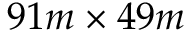<formula> <loc_0><loc_0><loc_500><loc_500>9 1 m \times 4 9 m</formula> 